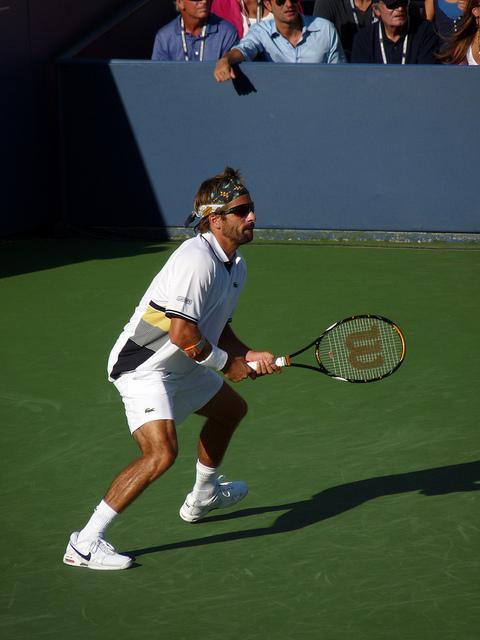How many people can be seen?
Give a very brief answer. 4. How many big orange are there in the image ?
Give a very brief answer. 0. 